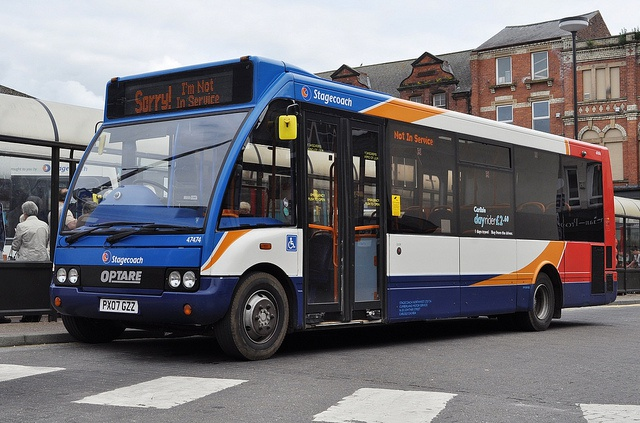Describe the objects in this image and their specific colors. I can see bus in lavender, black, gray, lightgray, and darkgray tones, bench in lavender, black, and gray tones, people in lavender, darkgray, gray, lightgray, and black tones, people in lavender, black, gray, darkgray, and blue tones, and people in lavender, gray, and black tones in this image. 